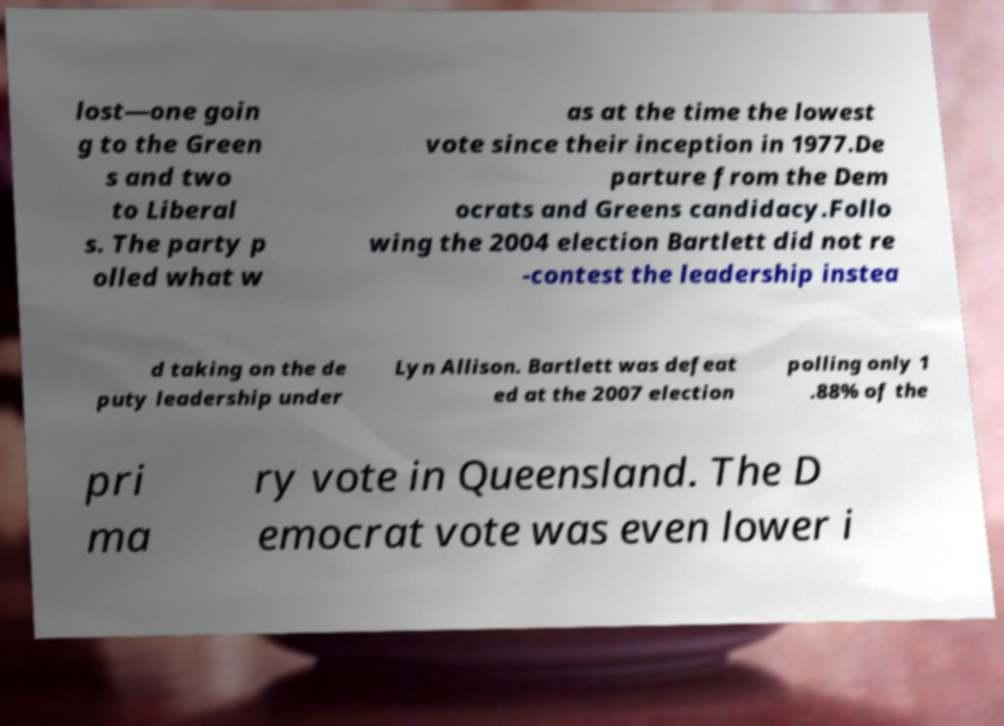Can you read and provide the text displayed in the image?This photo seems to have some interesting text. Can you extract and type it out for me? lost—one goin g to the Green s and two to Liberal s. The party p olled what w as at the time the lowest vote since their inception in 1977.De parture from the Dem ocrats and Greens candidacy.Follo wing the 2004 election Bartlett did not re -contest the leadership instea d taking on the de puty leadership under Lyn Allison. Bartlett was defeat ed at the 2007 election polling only 1 .88% of the pri ma ry vote in Queensland. The D emocrat vote was even lower i 